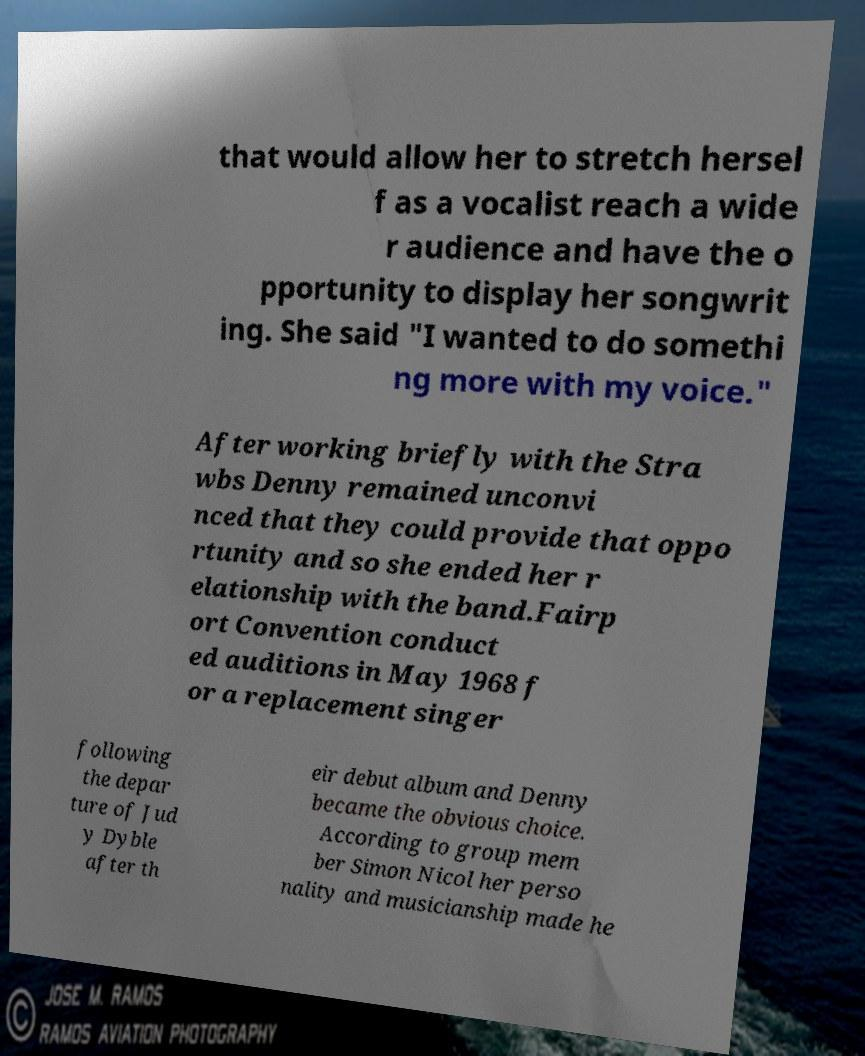Could you extract and type out the text from this image? that would allow her to stretch hersel f as a vocalist reach a wide r audience and have the o pportunity to display her songwrit ing. She said "I wanted to do somethi ng more with my voice." After working briefly with the Stra wbs Denny remained unconvi nced that they could provide that oppo rtunity and so she ended her r elationship with the band.Fairp ort Convention conduct ed auditions in May 1968 f or a replacement singer following the depar ture of Jud y Dyble after th eir debut album and Denny became the obvious choice. According to group mem ber Simon Nicol her perso nality and musicianship made he 